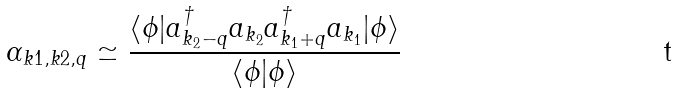Convert formula to latex. <formula><loc_0><loc_0><loc_500><loc_500>\alpha _ { k 1 , k 2 , q } \simeq \frac { \langle \phi | a ^ { \dagger } _ { k _ { 2 } - q } a _ { k _ { 2 } } a _ { k _ { 1 } + q } ^ { \dagger } a _ { k _ { 1 } } | \phi \rangle } { \langle \phi | \phi \rangle }</formula> 